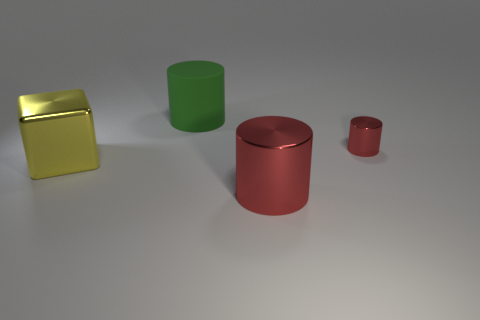Is there anything else that is the same shape as the large yellow thing?
Offer a very short reply. No. Are there any other things that have the same material as the green cylinder?
Provide a short and direct response. No. What color is the cylinder that is on the left side of the small red metal cylinder and in front of the large matte thing?
Provide a succinct answer. Red. Is the number of green cylinders greater than the number of gray matte objects?
Give a very brief answer. Yes. What number of things are yellow shiny things or objects that are in front of the rubber object?
Offer a terse response. 3. Is the size of the yellow thing the same as the green cylinder?
Your answer should be very brief. Yes. There is a tiny metal cylinder; are there any matte things behind it?
Keep it short and to the point. Yes. There is a shiny thing that is behind the large red object and to the right of the yellow metal object; how big is it?
Your answer should be very brief. Small. How many things are either green matte cylinders or red metal cylinders?
Provide a short and direct response. 3. Do the yellow metal object and the metal cylinder that is behind the metal cube have the same size?
Offer a very short reply. No. 